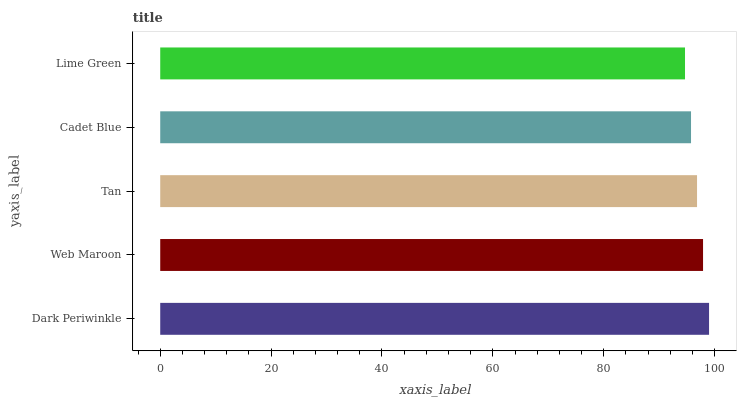Is Lime Green the minimum?
Answer yes or no. Yes. Is Dark Periwinkle the maximum?
Answer yes or no. Yes. Is Web Maroon the minimum?
Answer yes or no. No. Is Web Maroon the maximum?
Answer yes or no. No. Is Dark Periwinkle greater than Web Maroon?
Answer yes or no. Yes. Is Web Maroon less than Dark Periwinkle?
Answer yes or no. Yes. Is Web Maroon greater than Dark Periwinkle?
Answer yes or no. No. Is Dark Periwinkle less than Web Maroon?
Answer yes or no. No. Is Tan the high median?
Answer yes or no. Yes. Is Tan the low median?
Answer yes or no. Yes. Is Cadet Blue the high median?
Answer yes or no. No. Is Dark Periwinkle the low median?
Answer yes or no. No. 